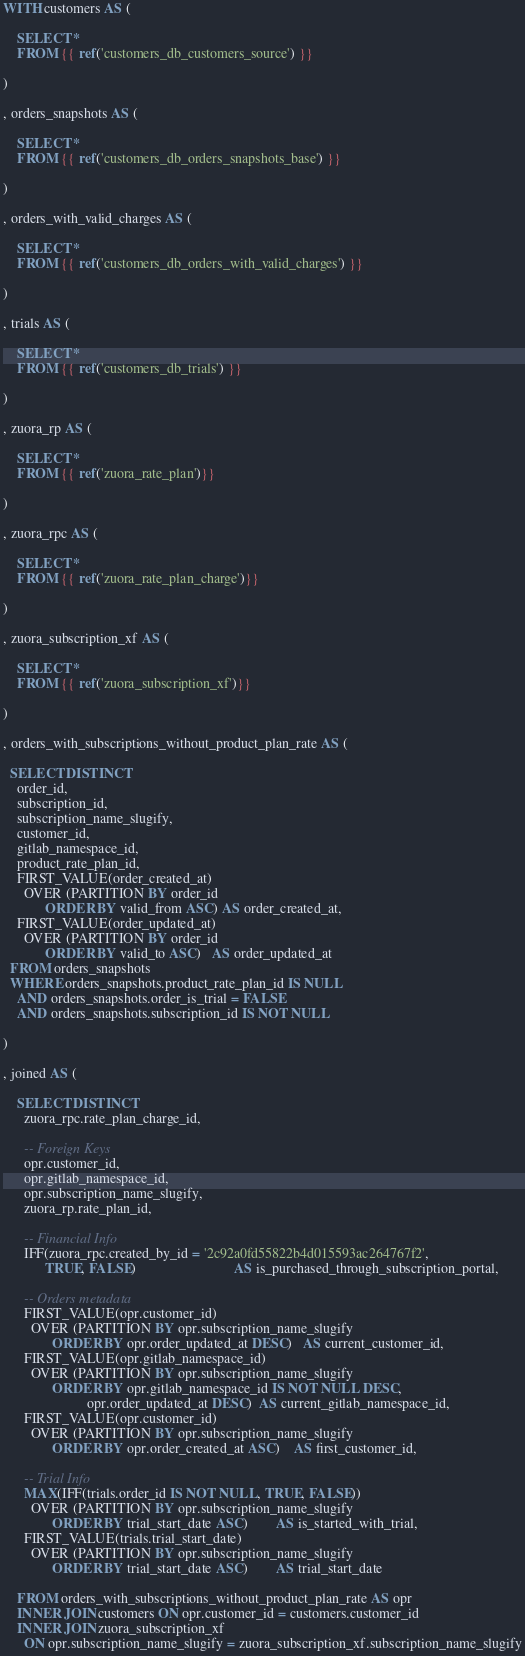<code> <loc_0><loc_0><loc_500><loc_500><_SQL_>WITH customers AS (
  
    SELECT * 
    FROM {{ ref('customers_db_customers_source') }}
  
)

, orders_snapshots AS (
  
    SELECT * 
    FROM {{ ref('customers_db_orders_snapshots_base') }}
  
)

, orders_with_valid_charges AS (
  
    SELECT * 
    FROM {{ ref('customers_db_orders_with_valid_charges') }}
  
)

, trials AS (
  
    SELECT * 
    FROM {{ ref('customers_db_trials') }}
  
)

, zuora_rp AS (
  
    SELECT *
    FROM {{ ref('zuora_rate_plan')}}
  
)

, zuora_rpc AS (
  
    SELECT *
    FROM {{ ref('zuora_rate_plan_charge')}}
  
)

, zuora_subscription_xf AS (
  
    SELECT *
    FROM {{ ref('zuora_subscription_xf')}}
  
)

, orders_with_subscriptions_without_product_plan_rate AS (
  
  SELECT DISTINCT
    order_id,
    subscription_id,
    subscription_name_slugify,
    customer_id,
    gitlab_namespace_id,
    product_rate_plan_id,
    FIRST_VALUE(order_created_at) 
      OVER (PARTITION BY order_id
            ORDER BY valid_from ASC) AS order_created_at,
    FIRST_VALUE(order_updated_at) 
      OVER (PARTITION BY order_id
            ORDER BY valid_to ASC)   AS order_updated_at
  FROM orders_snapshots
  WHERE orders_snapshots.product_rate_plan_id IS NULL 
    AND orders_snapshots.order_is_trial = FALSE
    AND orders_snapshots.subscription_id IS NOT NULL

)

, joined AS (
  
    SELECT DISTINCT
      zuora_rpc.rate_plan_charge_id,
      
      -- Foreign Keys
      opr.customer_id,
      opr.gitlab_namespace_id,
      opr.subscription_name_slugify,
      zuora_rp.rate_plan_id,
      
      -- Financial Info
      IFF(zuora_rpc.created_by_id = '2c92a0fd55822b4d015593ac264767f2',
            TRUE, FALSE)                            AS is_purchased_through_subscription_portal,
      
      -- Orders metadata
      FIRST_VALUE(opr.customer_id) 
        OVER (PARTITION BY opr.subscription_name_slugify 
              ORDER BY opr.order_updated_at DESC)   AS current_customer_id,
      FIRST_VALUE(opr.gitlab_namespace_id) 
        OVER (PARTITION BY opr.subscription_name_slugify 
              ORDER BY opr.gitlab_namespace_id IS NOT NULL DESC,
                        opr.order_updated_at DESC)  AS current_gitlab_namespace_id,
      FIRST_VALUE(opr.customer_id) 
        OVER (PARTITION BY opr.subscription_name_slugify 
              ORDER BY opr.order_created_at ASC)    AS first_customer_id,
      
      -- Trial Info                  
      MAX(IFF(trials.order_id IS NOT NULL, TRUE, FALSE)) 
        OVER (PARTITION BY opr.subscription_name_slugify
              ORDER BY trial_start_date ASC)        AS is_started_with_trial,
      FIRST_VALUE(trials.trial_start_date)
        OVER (PARTITION BY opr.subscription_name_slugify
              ORDER BY trial_start_date ASC)        AS trial_start_date
    
    FROM orders_with_subscriptions_without_product_plan_rate AS opr 
    INNER JOIN customers ON opr.customer_id = customers.customer_id
    INNER JOIN zuora_subscription_xf
      ON opr.subscription_name_slugify = zuora_subscription_xf.subscription_name_slugify</code> 